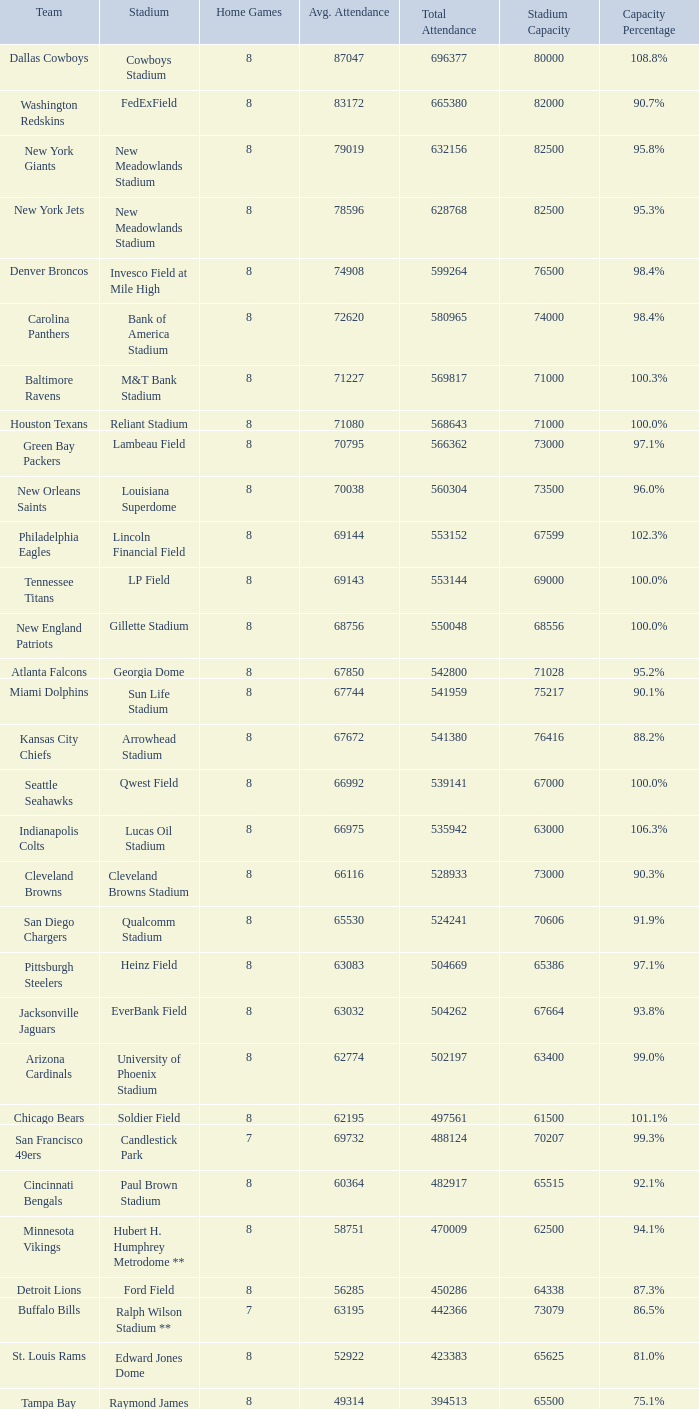What squad had a capacity of 10 Philadelphia Eagles. 